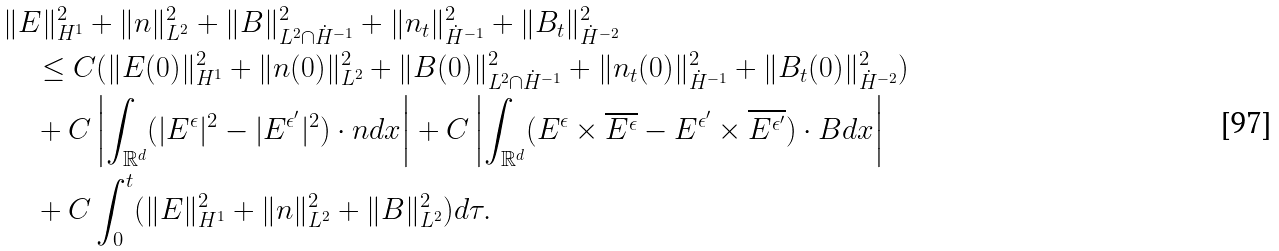<formula> <loc_0><loc_0><loc_500><loc_500>& \| E \| _ { H ^ { 1 } } ^ { 2 } + \| n \| _ { L ^ { 2 } } ^ { 2 } + \| B \| _ { L ^ { 2 } \cap \dot { H } ^ { - 1 } } ^ { 2 } + \| n _ { t } \| _ { \dot { H } ^ { - 1 } } ^ { 2 } + \| B _ { t } \| _ { \dot { H } ^ { - 2 } } ^ { 2 } \\ & \quad \leq C ( \| E ( 0 ) \| _ { H ^ { 1 } } ^ { 2 } + \| n ( 0 ) \| _ { L ^ { 2 } } ^ { 2 } + \| B ( 0 ) \| _ { L ^ { 2 } \cap \dot { H } ^ { - 1 } } ^ { 2 } + \| n _ { t } ( 0 ) \| _ { \dot { H } ^ { - 1 } } ^ { 2 } + \| B _ { t } ( 0 ) \| _ { \dot { H } ^ { - 2 } } ^ { 2 } ) \\ & \quad + C \left | \int _ { \mathbb { R } ^ { d } } ( | E ^ { \epsilon } | ^ { 2 } - | E ^ { \epsilon ^ { \prime } } | ^ { 2 } ) \cdot n d x \right | + C \left | \int _ { \mathbb { R } ^ { d } } ( E ^ { \epsilon } \times \overline { E ^ { \epsilon } } - E ^ { \epsilon ^ { \prime } } \times \overline { E ^ { \epsilon ^ { \prime } } } ) \cdot B d x \right | \\ & \quad + C \int _ { 0 } ^ { t } ( \| E \| _ { H ^ { 1 } } ^ { 2 } + \| n \| _ { L ^ { 2 } } ^ { 2 } + \| B \| _ { L ^ { 2 } } ^ { 2 } ) d \tau .</formula> 